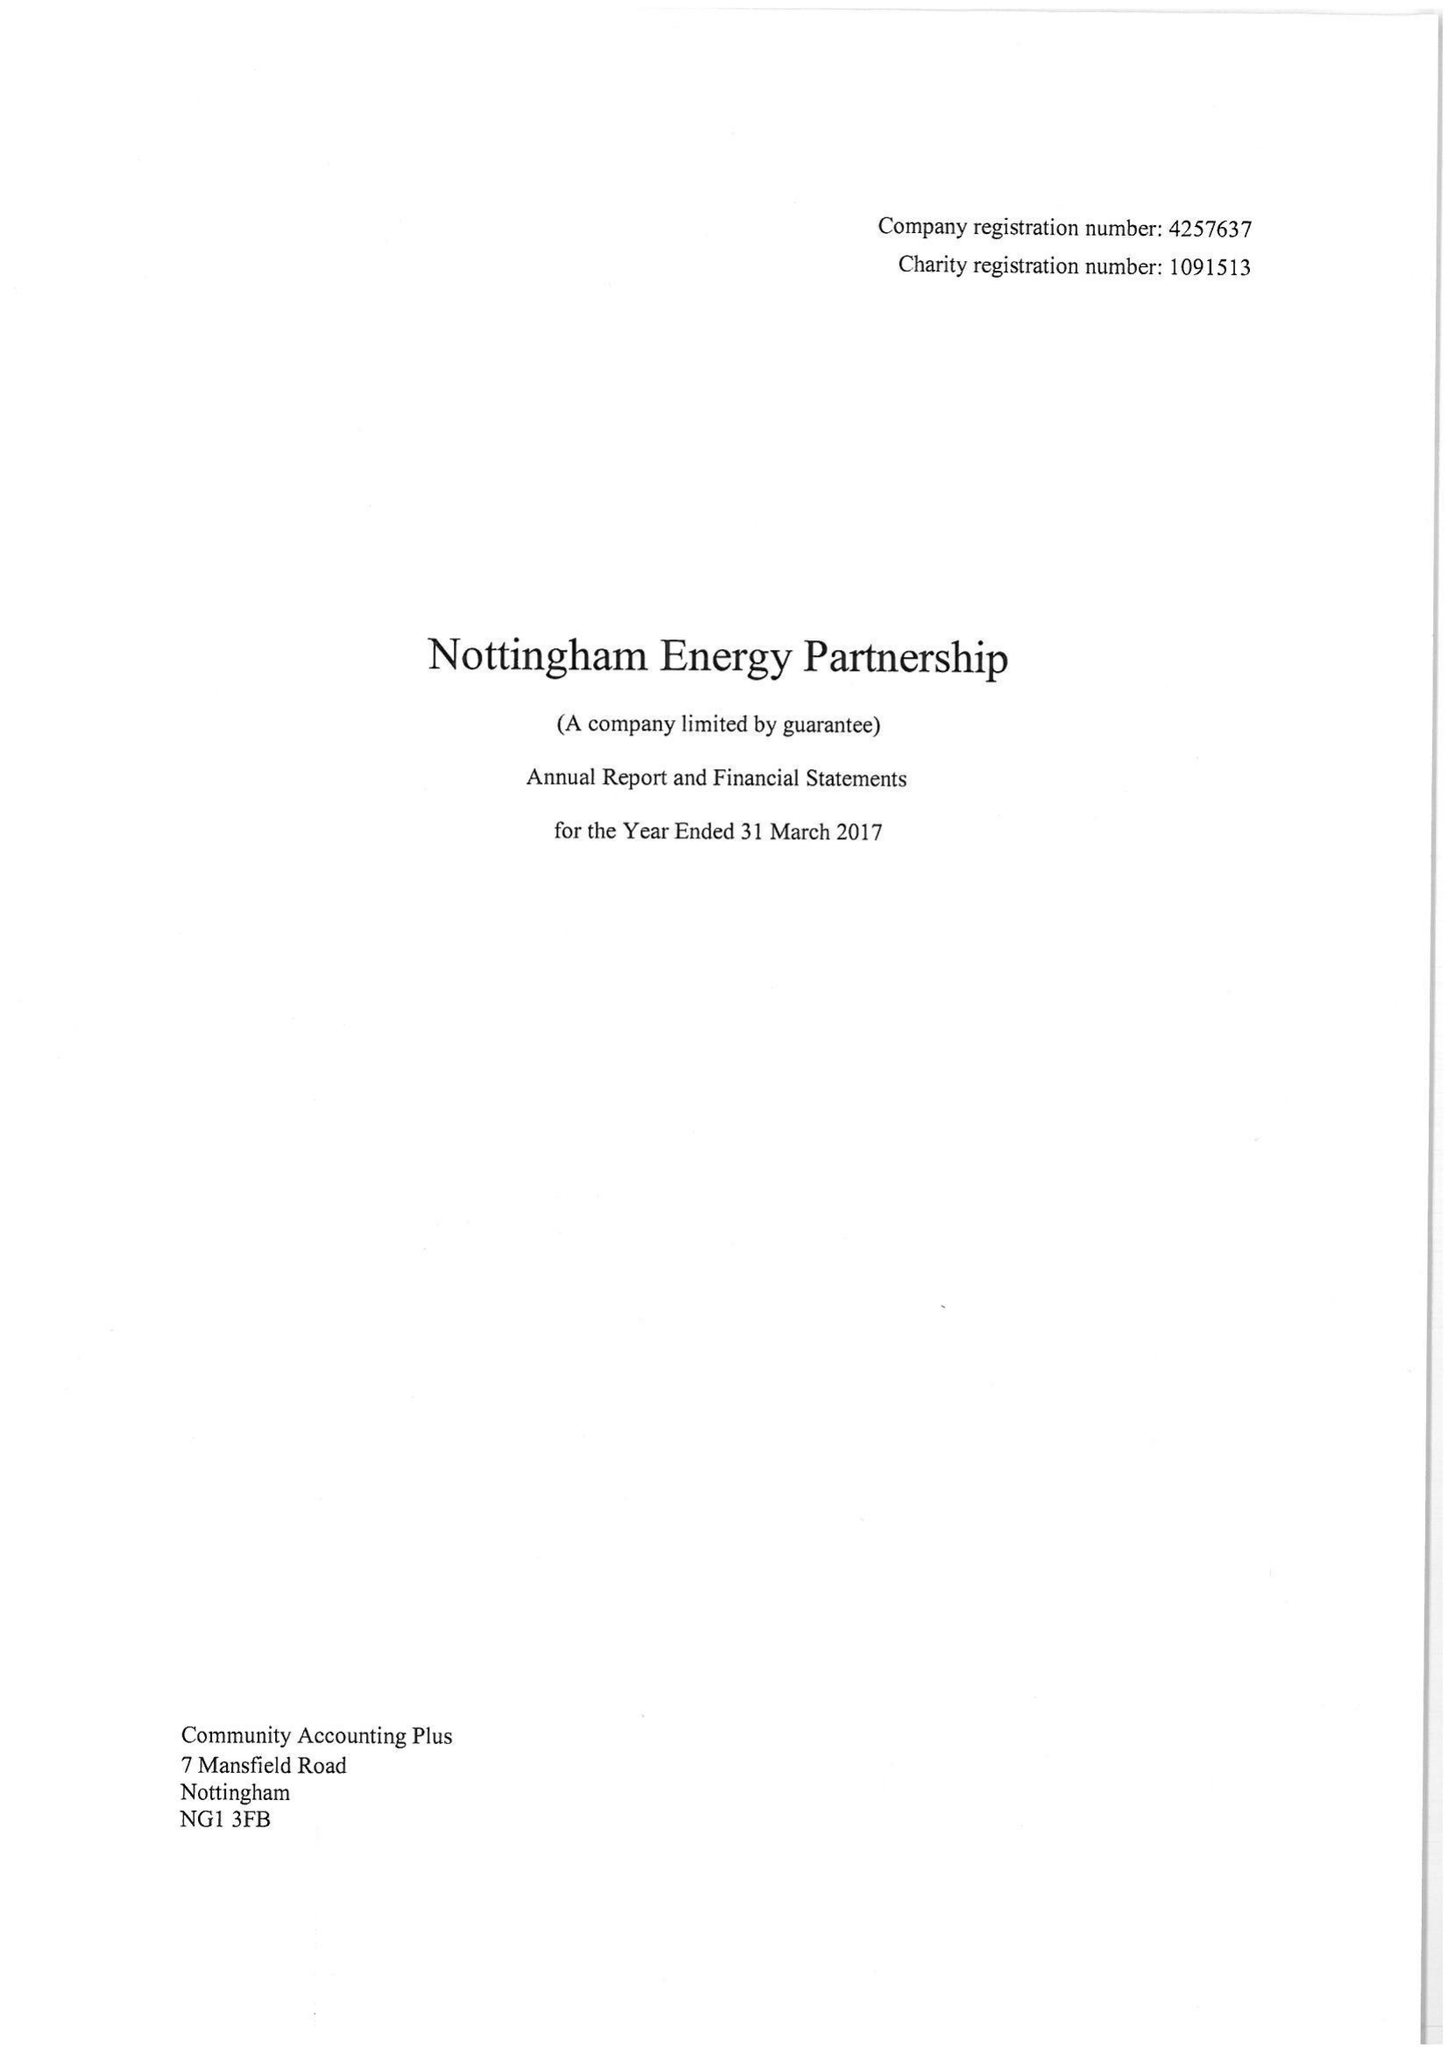What is the value for the income_annually_in_british_pounds?
Answer the question using a single word or phrase. 418149.00 